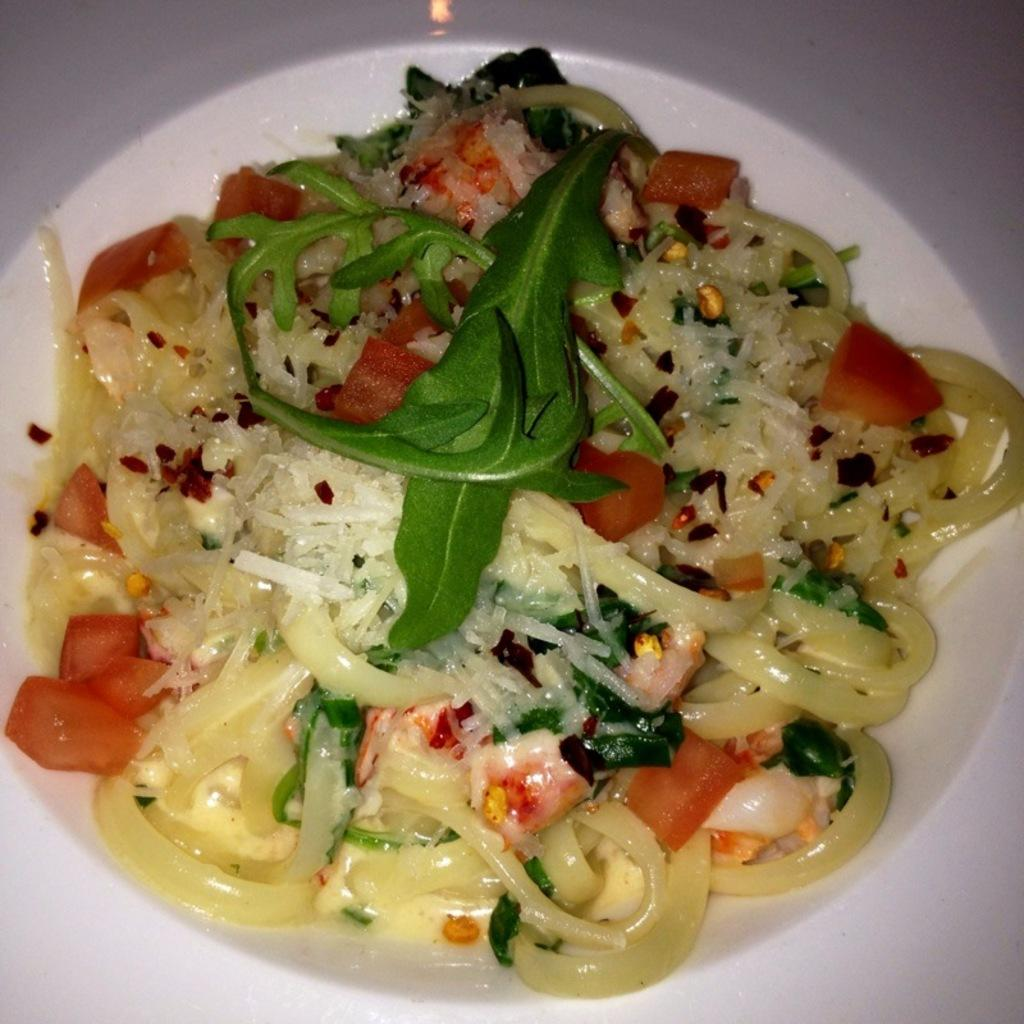What object is present in the image that typically holds food? There is a plate in the image. What is on the plate? The plate contains food. Can you see a bee playing a guitar on the plate in the image? No, there is no bee or guitar present on the plate in the image. 